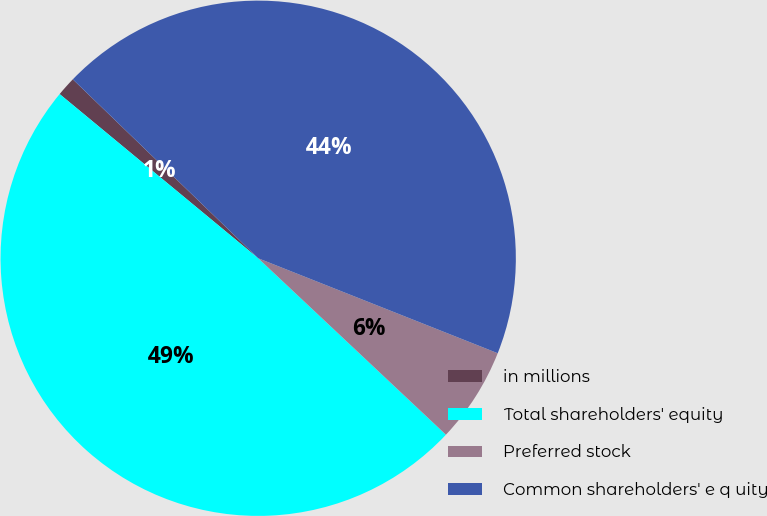<chart> <loc_0><loc_0><loc_500><loc_500><pie_chart><fcel>in millions<fcel>Total shareholders' equity<fcel>Preferred stock<fcel>Common shareholders' e q uity<nl><fcel>1.22%<fcel>48.99%<fcel>6.0%<fcel>43.79%<nl></chart> 